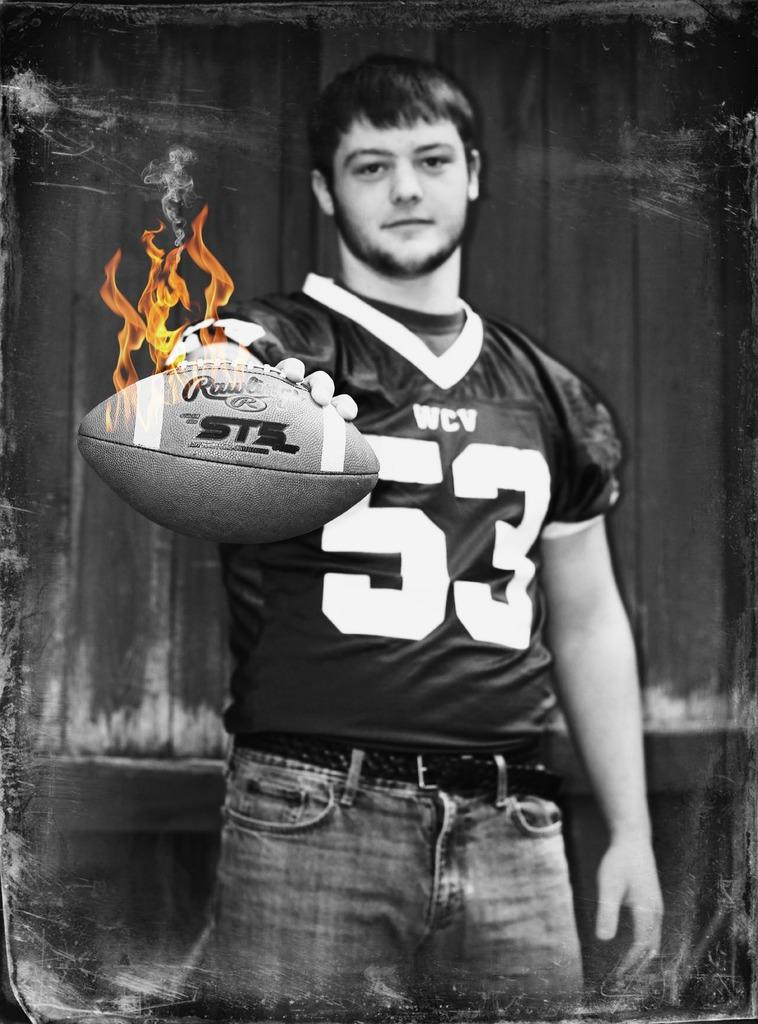Who is present in the image? There is a man in the image. What is the man holding in his hand? The man is holding a ball in his left hand. What is unusual about the ball? The ball appears to be on fire. What can be seen in the background of the image? There is a wall in the background of the image. How many fingers does the man have on his right hand in the image? The provided facts do not mention the man's fingers or his right hand, so it cannot be determined from the image. 